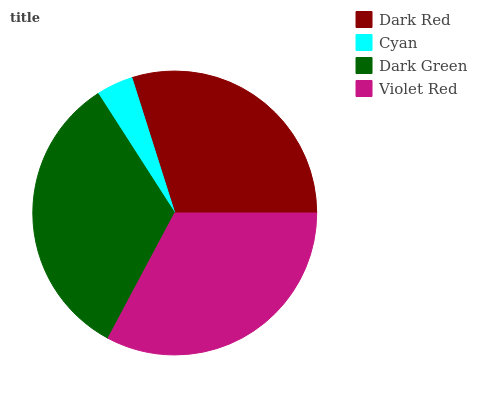Is Cyan the minimum?
Answer yes or no. Yes. Is Dark Green the maximum?
Answer yes or no. Yes. Is Dark Green the minimum?
Answer yes or no. No. Is Cyan the maximum?
Answer yes or no. No. Is Dark Green greater than Cyan?
Answer yes or no. Yes. Is Cyan less than Dark Green?
Answer yes or no. Yes. Is Cyan greater than Dark Green?
Answer yes or no. No. Is Dark Green less than Cyan?
Answer yes or no. No. Is Violet Red the high median?
Answer yes or no. Yes. Is Dark Red the low median?
Answer yes or no. Yes. Is Dark Green the high median?
Answer yes or no. No. Is Cyan the low median?
Answer yes or no. No. 